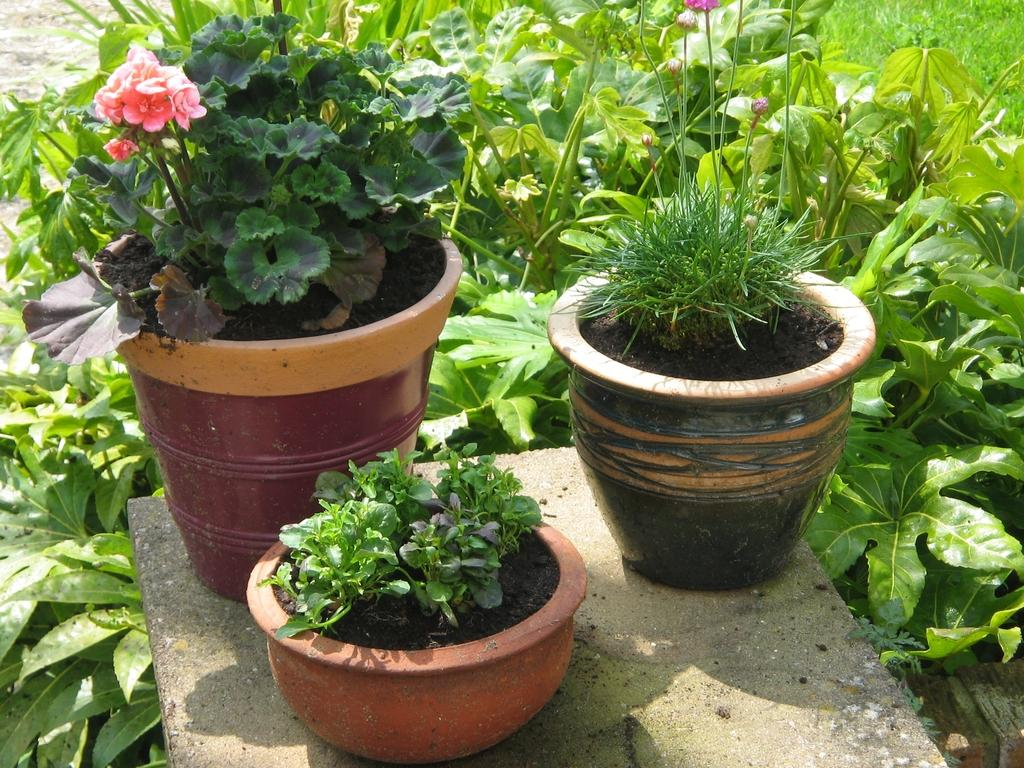What type of plants can be seen on the fence in the image? There are house plants on a fence in the image. What other type of plants can be seen in the image? There are flowering plants in the background of the image. Can you tell if the image was taken during the day or night? The image was likely taken during the day. What is the chance of a cannon appearing in the image? There is no cannon present in the image, so it is not possible to determine the chance of it appearing. 